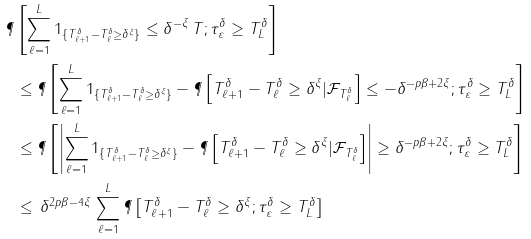<formula> <loc_0><loc_0><loc_500><loc_500>\P & \left [ \sum _ { \ell = 1 } ^ { L } 1 _ { \{ T _ { \ell + 1 } ^ { \delta } - T _ { \ell } ^ { \delta } \geq \delta ^ { \xi } \} } \leq \delta ^ { - \xi } \, T ; \tau _ { \varepsilon } ^ { \delta } \geq T _ { L } ^ { \delta } \right ] \\ & \leq \P \left [ \sum _ { \ell = 1 } ^ { L } 1 _ { \{ T _ { \ell + 1 } ^ { \delta } - T _ { \ell } ^ { \delta } \geq \delta ^ { \xi } \} } - \P \left [ T _ { \ell + 1 } ^ { \delta } - T _ { \ell } ^ { \delta } \geq \delta ^ { \xi } | \mathcal { F } _ { T _ { \ell } ^ { \delta } } \right ] \leq - \delta ^ { - p \beta + 2 \xi } ; \tau _ { \varepsilon } ^ { \delta } \geq T _ { L } ^ { \delta } \right ] \\ & \leq \P \left [ \left | \sum _ { \ell = 1 } ^ { L } 1 _ { \{ T _ { \ell + 1 } ^ { \delta } - T _ { \ell } ^ { \delta } \geq \delta ^ { \xi } \} } - \P \left [ T _ { \ell + 1 } ^ { \delta } - T _ { \ell } ^ { \delta } \geq \delta ^ { \xi } | \mathcal { F } _ { T _ { \ell } ^ { \delta } } \right ] \right | \geq \delta ^ { - p \beta + 2 \xi } ; \tau _ { \varepsilon } ^ { \delta } \geq T _ { L } ^ { \delta } \right ] \\ & \leq \, \delta ^ { 2 p \beta - 4 \xi } \, \sum _ { \ell = 1 } ^ { L } \P \left [ T _ { \ell + 1 } ^ { \delta } - T _ { \ell } ^ { \delta } \geq \delta ^ { \xi } ; \tau _ { \varepsilon } ^ { \delta } \geq T _ { L } ^ { \delta } \right ]</formula> 